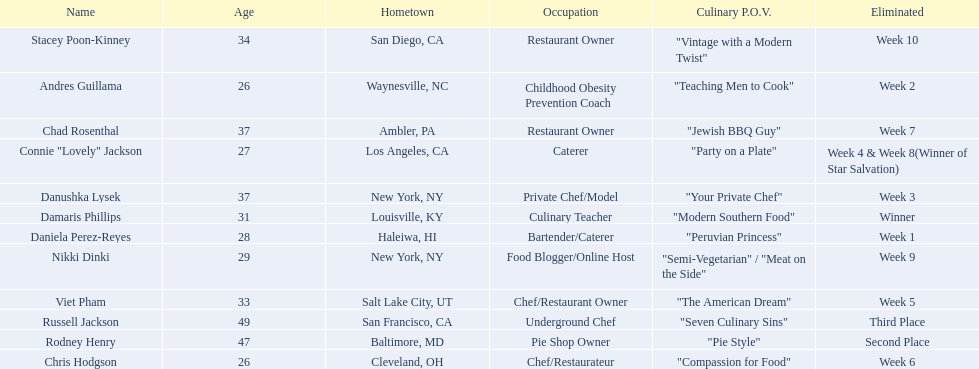Who are the  food network stars? Damaris Phillips, Rodney Henry, Russell Jackson, Stacey Poon-Kinney, Nikki Dinki, Chad Rosenthal, Chris Hodgson, Viet Pham, Connie "Lovely" Jackson, Danushka Lysek, Andres Guillama, Daniela Perez-Reyes. When did nikki dinki get eliminated? Week 9. When did viet pham get eliminated? Week 5. Which week came first? Week 5. Who was it that was eliminated week 5? Viet Pham. 